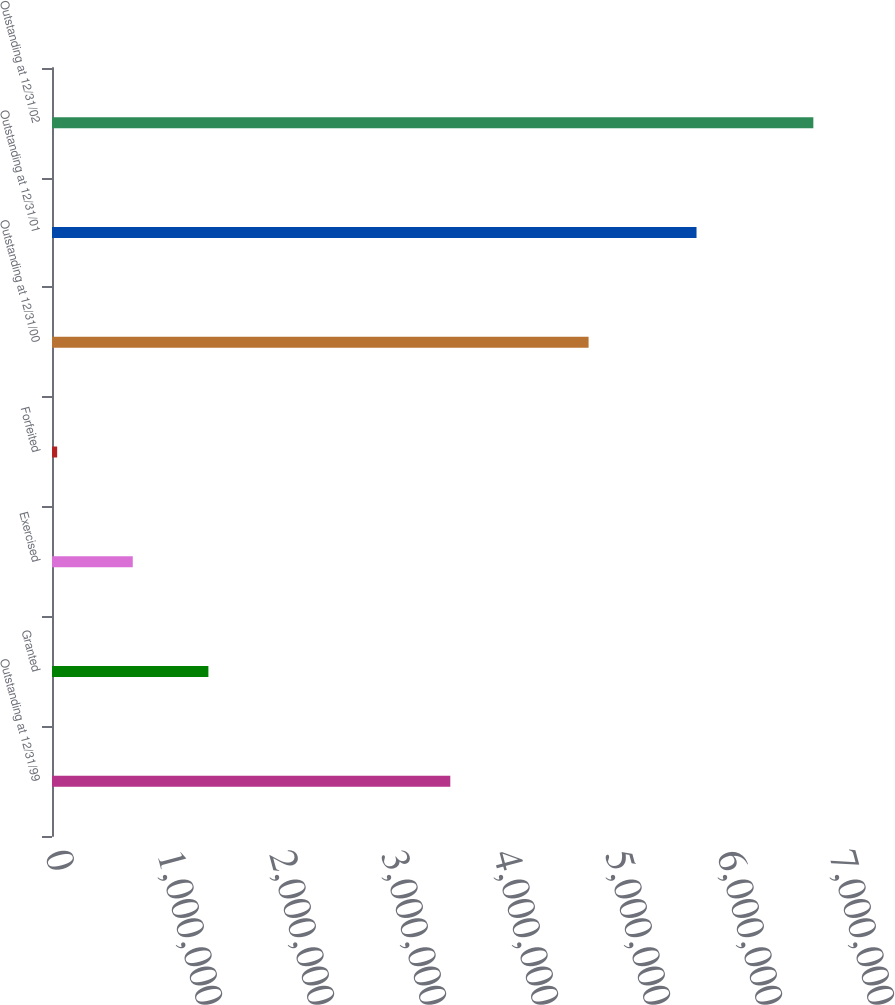<chart> <loc_0><loc_0><loc_500><loc_500><bar_chart><fcel>Outstanding at 12/31/99<fcel>Granted<fcel>Exercised<fcel>Forfeited<fcel>Outstanding at 12/31/00<fcel>Outstanding at 12/31/01<fcel>Outstanding at 12/31/02<nl><fcel>3.55621e+06<fcel>1.39641e+06<fcel>721255<fcel>46100<fcel>4.79091e+06<fcel>5.75465e+06<fcel>6.79765e+06<nl></chart> 